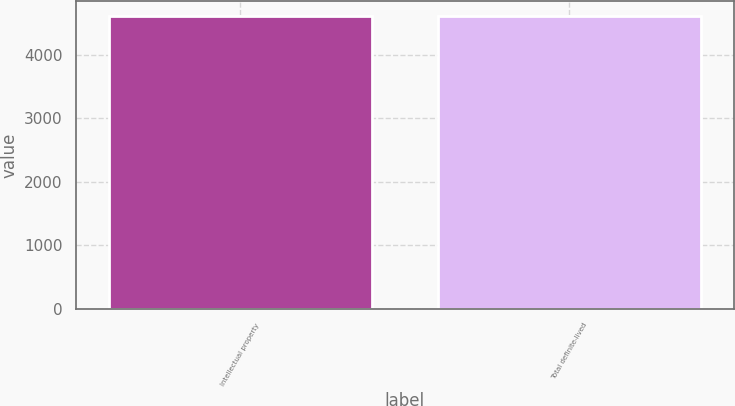<chart> <loc_0><loc_0><loc_500><loc_500><bar_chart><fcel>Intellectual property<fcel>Total definite-lived<nl><fcel>4609<fcel>4609.1<nl></chart> 